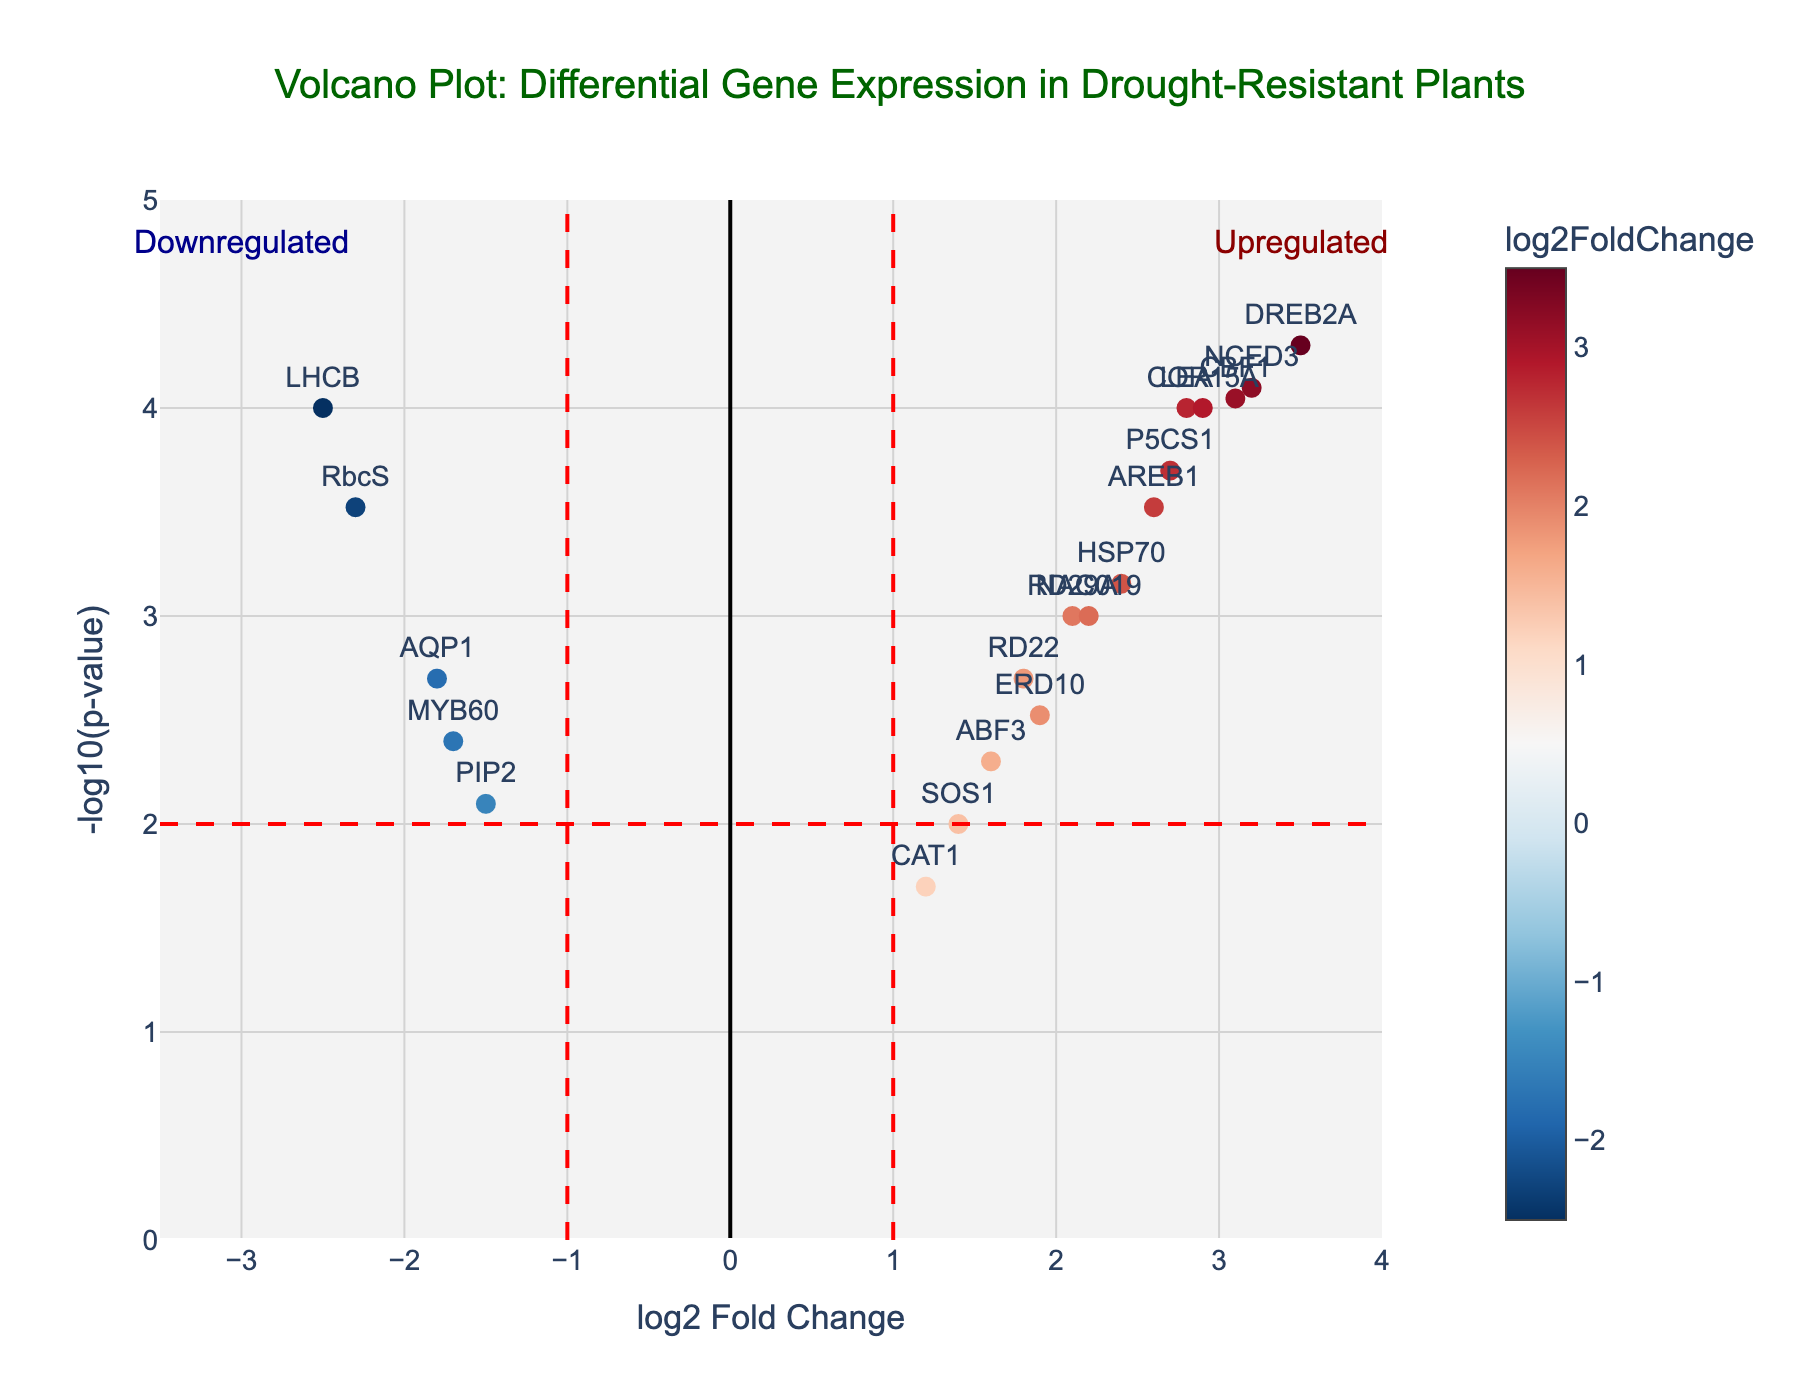What's the title of the figure? The title is placed at the top center of the figure, formatted in a prominent dark green font. It reads "Volcano Plot: Differential Gene Expression in Drought-Resistant Plants".
Answer: Volcano Plot: Differential Gene Expression in Drought-Resistant Plants What do the x-axis and y-axis represent? The x-axis represents the log2 Fold Change, and the y-axis represents the negative logarithm of the p-value (-log10(p-value)). These labels are clearly shown on the axes of the plot.
Answer: log2 Fold Change and -log10(p-value) How do the red dashed lines on the plot help interpret the data? The vertical dashed lines at log2 Fold Change of -1 and 1 mark thresholds for significant fold changes. The horizontal dashed line at -log10(p-value) of 2 marks the threshold for significant p-values (p-value < 0.01). Genes outside these lines are considered significantly up- or downregulated.
Answer: Mark thresholds for significant fold changes and p-values Which genes are among the most upregulated according to the plot? Look for the genes positioned farthest to the right on the x-axis (log2 Fold Change > 1) and highest on the y-axis (-log10(p-value) > 2). DREB2A, NCED3, and CBF1 are among the most upregulated genes in the dataset.
Answer: DREB2A, NCED3, CBF1 Which gene has the highest p-value among the downregulated ones? Focus on the left side of the plot and look for the gene that is lowest on the y-axis. The gene MYB60 has the highest p-value among the downregulated ones with a log2 Fold Change of -1.7.
Answer: MYB60 How many genes are shown in the plot? Count the data points representing genes. According to the plot, there are 20 genes displayed.
Answer: 20 Are there more upregulated or downregulated genes? Compare the number of data points on the right side (+log2 Fold Change) with those on the left side (-log2 Fold Change) of the y-axis. There are more upregulated genes (12) compared to downregulated genes (8).
Answer: More upregulated genes Which gene is closest to the threshold for significance on both axes? Look for the gene closest to the intersecting red dashed lines at log2 Fold Change of ±1 and -log10(p-value) of 2. The gene ABF3 with log2 Fold Change of 1.6 and -log10(p-value) around 2.3 is close to this threshold.
Answer: ABF3 What is the average log2 Fold Change of the upregulated genes? Sum the log2 Fold Change values of all upregulated genes (positive values) and divide by the number of these genes. (2.8 + 3.5 + 2.1 + 1.9 + 2.7 + 3.2 + 1.6 + 2.4 + 3.1 + 2.9 + 2.2 + 2.6) / 12 = 2.517.
Answer: 2.517 Which genes are considered significantly downregulated and have a fold change threshold of less than -1? Identify the genes on the left side of the plot (negative log2 Fold Change) that are below the horizontal dashed line at -log10(p-value) of 2. AQP1, RbcS, and LHCB fulfill these conditions.
Answer: AQP1, RbcS, LHCB 